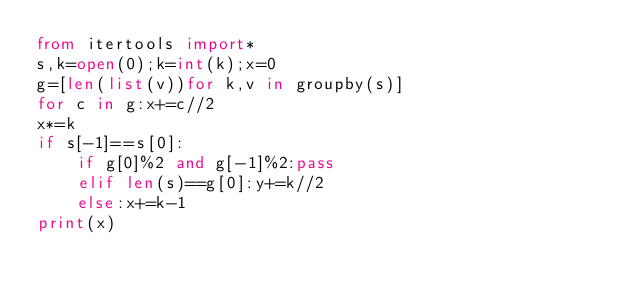Convert code to text. <code><loc_0><loc_0><loc_500><loc_500><_Python_>from itertools import*
s,k=open(0);k=int(k);x=0
g=[len(list(v))for k,v in groupby(s)]
for c in g:x+=c//2
x*=k
if s[-1]==s[0]:
	if g[0]%2 and g[-1]%2:pass
	elif len(s)==g[0]:y+=k//2
	else:x+=k-1
print(x)</code> 